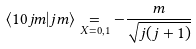<formula> <loc_0><loc_0><loc_500><loc_500>\langle 1 0 j m | j m \rangle \underset { X = 0 , 1 } { = } - \frac { m } { \sqrt { j ( j + 1 ) } }</formula> 